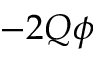Convert formula to latex. <formula><loc_0><loc_0><loc_500><loc_500>- 2 Q \phi</formula> 